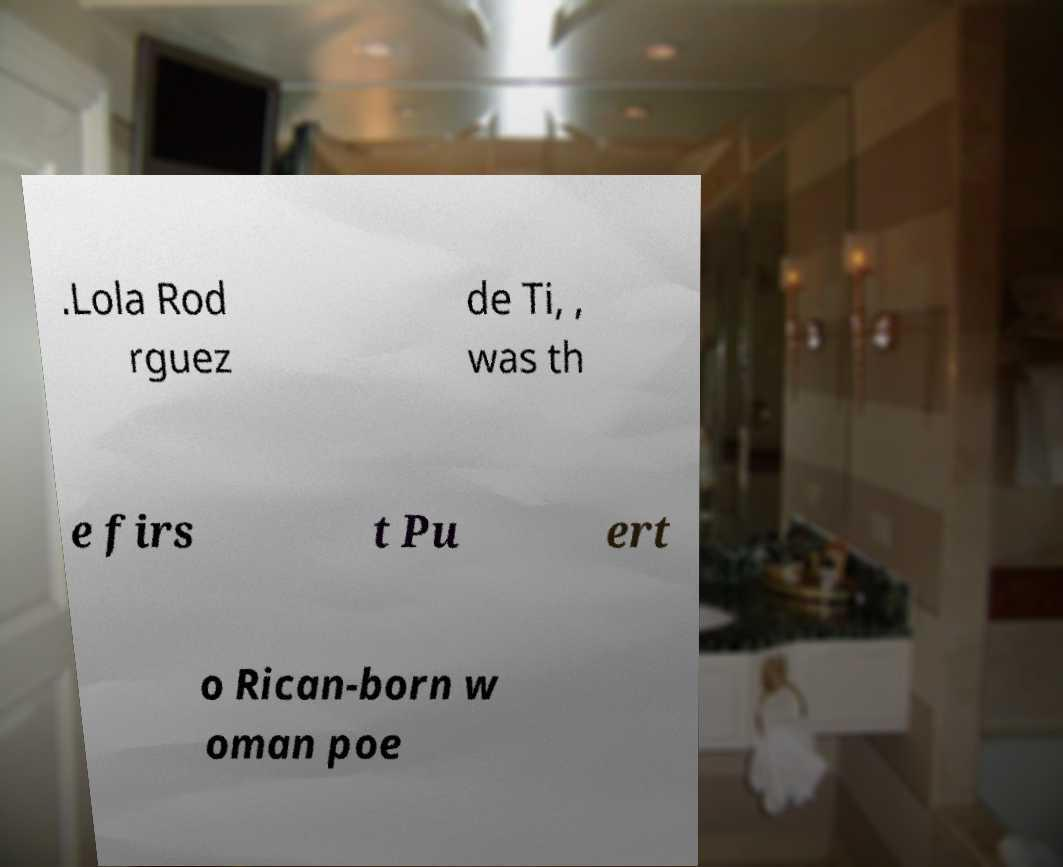For documentation purposes, I need the text within this image transcribed. Could you provide that? .Lola Rod rguez de Ti, , was th e firs t Pu ert o Rican-born w oman poe 